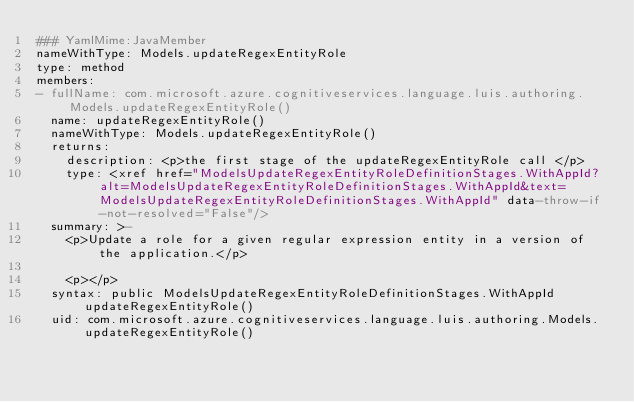Convert code to text. <code><loc_0><loc_0><loc_500><loc_500><_YAML_>### YamlMime:JavaMember
nameWithType: Models.updateRegexEntityRole
type: method
members:
- fullName: com.microsoft.azure.cognitiveservices.language.luis.authoring.Models.updateRegexEntityRole()
  name: updateRegexEntityRole()
  nameWithType: Models.updateRegexEntityRole()
  returns:
    description: <p>the first stage of the updateRegexEntityRole call </p>
    type: <xref href="ModelsUpdateRegexEntityRoleDefinitionStages.WithAppId?alt=ModelsUpdateRegexEntityRoleDefinitionStages.WithAppId&text=ModelsUpdateRegexEntityRoleDefinitionStages.WithAppId" data-throw-if-not-resolved="False"/>
  summary: >-
    <p>Update a role for a given regular expression entity in a version of the application.</p>

    <p></p>
  syntax: public ModelsUpdateRegexEntityRoleDefinitionStages.WithAppId updateRegexEntityRole()
  uid: com.microsoft.azure.cognitiveservices.language.luis.authoring.Models.updateRegexEntityRole()</code> 